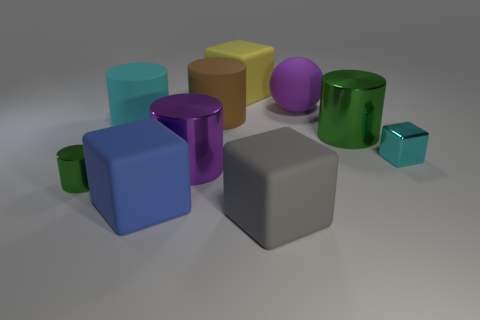Subtract 1 cylinders. How many cylinders are left? 4 Subtract all small green cylinders. How many cylinders are left? 4 Subtract all cyan cylinders. How many cylinders are left? 4 Subtract all blue cylinders. Subtract all gray balls. How many cylinders are left? 5 Subtract all blocks. How many objects are left? 6 Add 10 tiny red balls. How many tiny red balls exist? 10 Subtract 0 yellow cylinders. How many objects are left? 10 Subtract all small cyan spheres. Subtract all rubber balls. How many objects are left? 9 Add 4 purple metallic cylinders. How many purple metallic cylinders are left? 5 